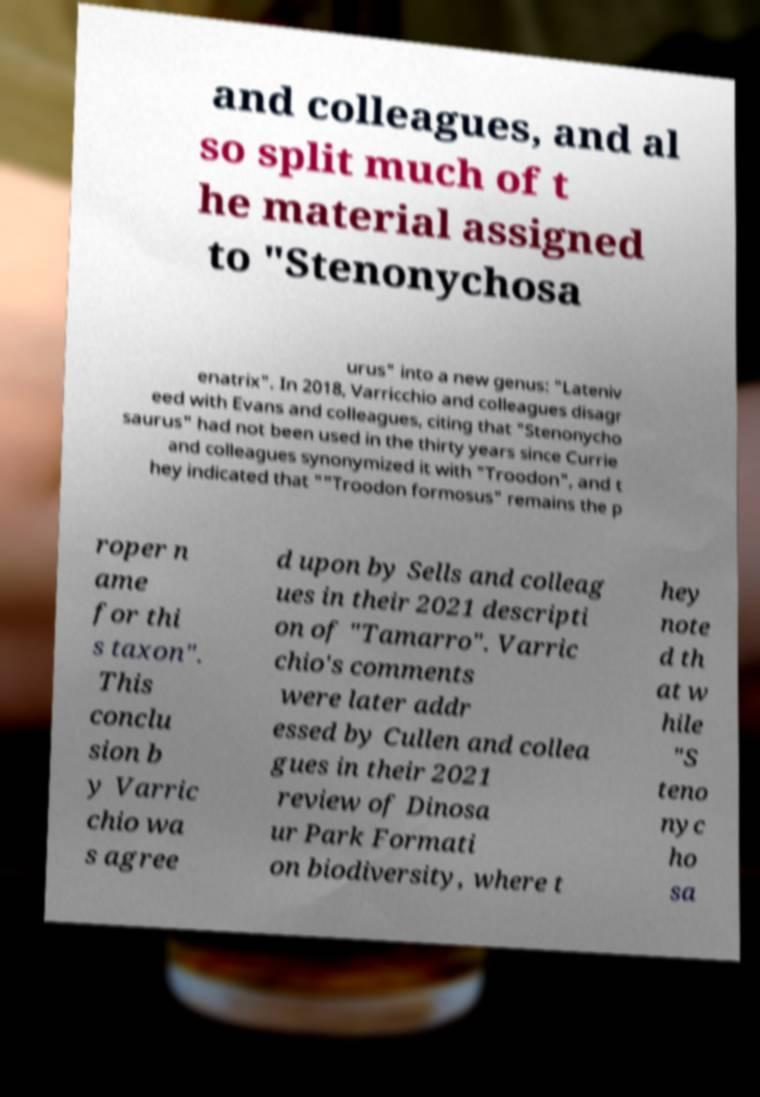Could you extract and type out the text from this image? and colleagues, and al so split much of t he material assigned to "Stenonychosa urus" into a new genus: "Lateniv enatrix". In 2018, Varricchio and colleagues disagr eed with Evans and colleagues, citing that "Stenonycho saurus" had not been used in the thirty years since Currie and colleagues synonymized it with "Troodon", and t hey indicated that ""Troodon formosus" remains the p roper n ame for thi s taxon". This conclu sion b y Varric chio wa s agree d upon by Sells and colleag ues in their 2021 descripti on of "Tamarro". Varric chio's comments were later addr essed by Cullen and collea gues in their 2021 review of Dinosa ur Park Formati on biodiversity, where t hey note d th at w hile "S teno nyc ho sa 